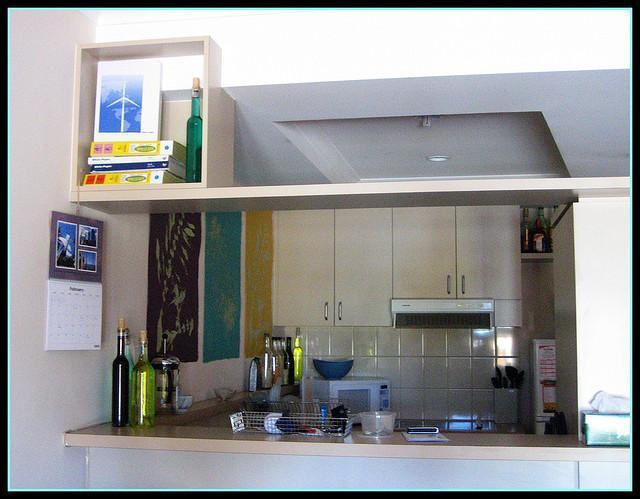How many chairs are there?
Give a very brief answer. 0. 